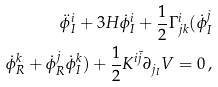Convert formula to latex. <formula><loc_0><loc_0><loc_500><loc_500>\ddot { \phi } ^ { i } _ { I } + 3 H \dot { \phi } ^ { i } _ { I } + \frac { 1 } { 2 } \Gamma ^ { i } _ { j k } ( \dot { \phi } ^ { j } _ { I } \\ \dot { \phi } ^ { k } _ { R } + \dot { \phi } ^ { j } _ { R } \dot { \phi } ^ { k } _ { I } ) + \frac { 1 } { 2 } K ^ { i \bar { j } } \partial _ { j _ { I } } V = 0 \, ,</formula> 